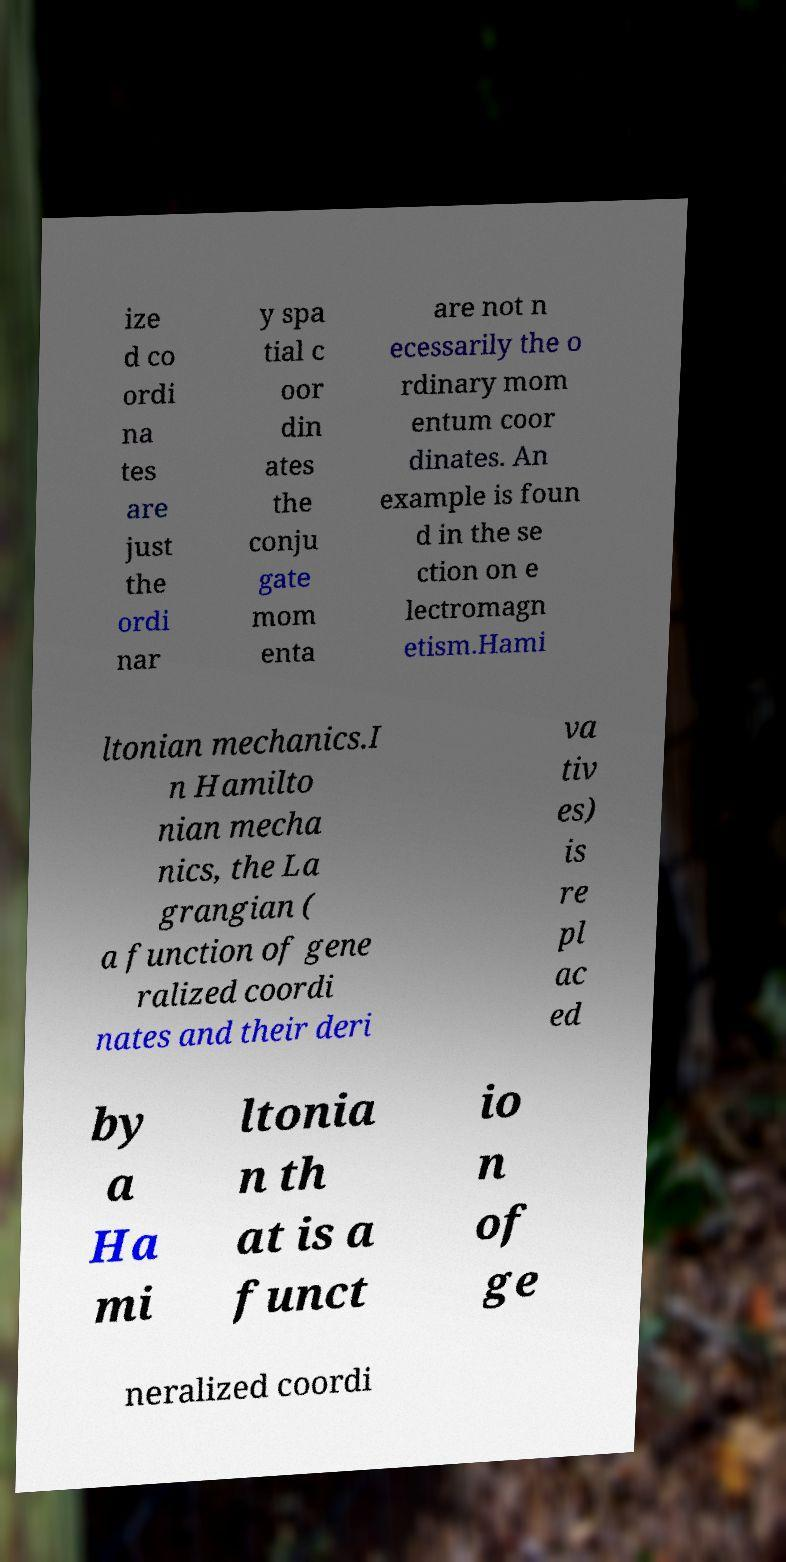Could you assist in decoding the text presented in this image and type it out clearly? ize d co ordi na tes are just the ordi nar y spa tial c oor din ates the conju gate mom enta are not n ecessarily the o rdinary mom entum coor dinates. An example is foun d in the se ction on e lectromagn etism.Hami ltonian mechanics.I n Hamilto nian mecha nics, the La grangian ( a function of gene ralized coordi nates and their deri va tiv es) is re pl ac ed by a Ha mi ltonia n th at is a funct io n of ge neralized coordi 